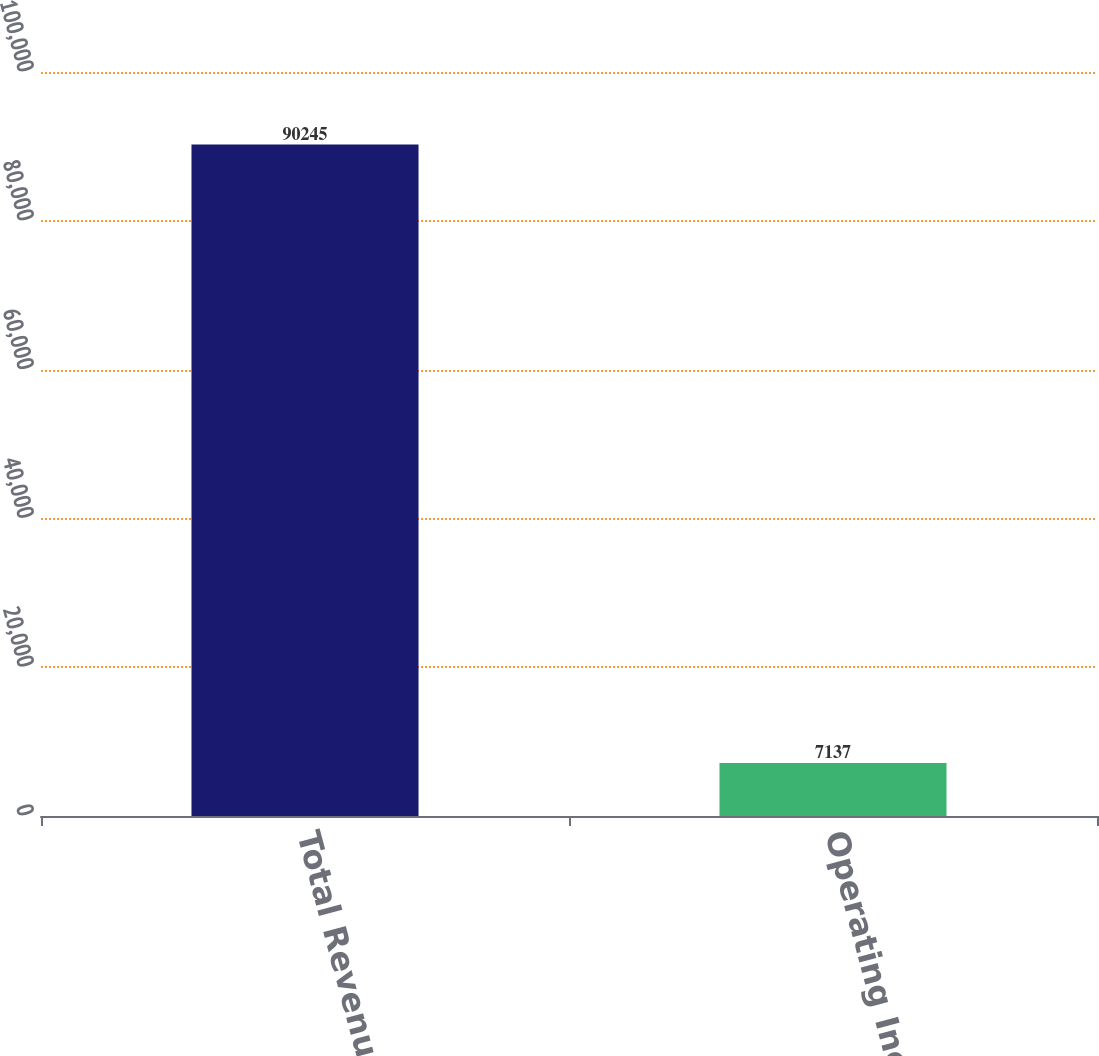Convert chart. <chart><loc_0><loc_0><loc_500><loc_500><bar_chart><fcel>Total Revenues<fcel>Operating Income<nl><fcel>90245<fcel>7137<nl></chart> 